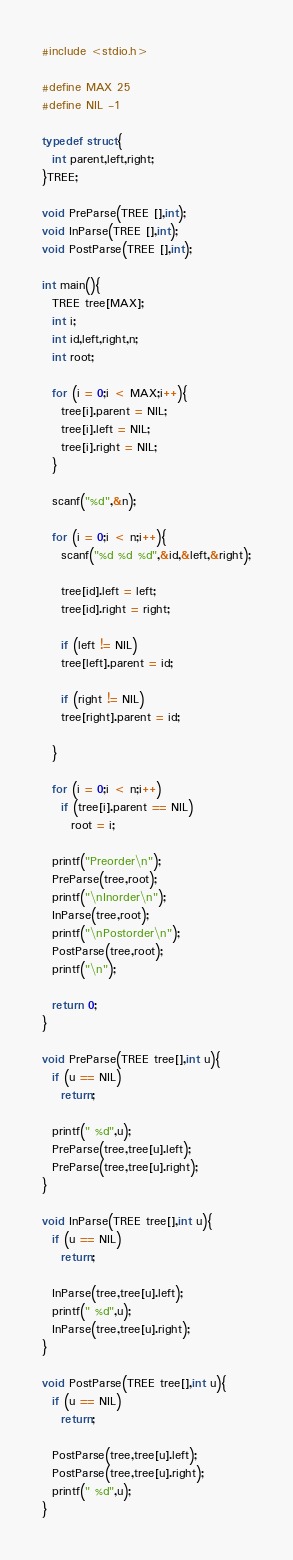Convert code to text. <code><loc_0><loc_0><loc_500><loc_500><_C_>#include <stdio.h>

#define MAX 25
#define NIL -1

typedef struct{
  int parent,left,right;
}TREE;

void PreParse(TREE [],int);
void InParse(TREE [],int);
void PostParse(TREE [],int);

int main(){
  TREE tree[MAX];
  int i;
  int id,left,right,n;
  int root;

  for (i = 0;i < MAX;i++){
    tree[i].parent = NIL;
    tree[i].left = NIL;
    tree[i].right = NIL;
  }

  scanf("%d",&n);

  for (i = 0;i < n;i++){
    scanf("%d %d %d",&id,&left,&right);
    
    tree[id].left = left;
    tree[id].right = right;

    if (left != NIL)
    tree[left].parent = id;

    if (right != NIL)
    tree[right].parent = id;

  }

  for (i = 0;i < n;i++)
    if (tree[i].parent == NIL)
      root = i;
  
  printf("Preorder\n");
  PreParse(tree,root);
  printf("\nInorder\n");
  InParse(tree,root);
  printf("\nPostorder\n");
  PostParse(tree,root);
  printf("\n");
  
  return 0;
}

void PreParse(TREE tree[],int u){
  if (u == NIL)
    return;

  printf(" %d",u);
  PreParse(tree,tree[u].left);
  PreParse(tree,tree[u].right);
}

void InParse(TREE tree[],int u){
  if (u == NIL)
    return;

  InParse(tree,tree[u].left);
  printf(" %d",u);
  InParse(tree,tree[u].right);
}

void PostParse(TREE tree[],int u){
  if (u == NIL)
    return;

  PostParse(tree,tree[u].left);
  PostParse(tree,tree[u].right);
  printf(" %d",u);
}

</code> 